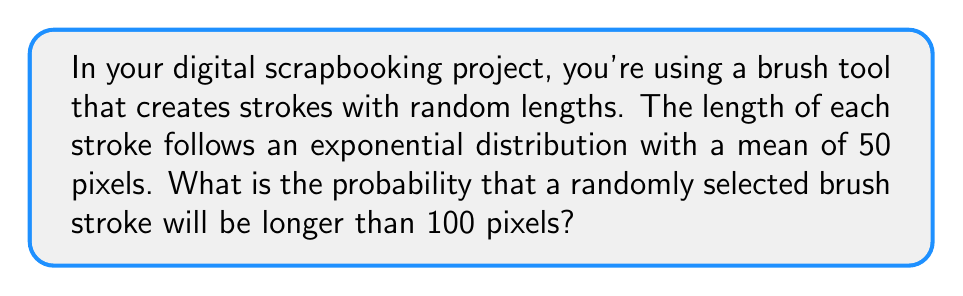Provide a solution to this math problem. Let's approach this step-by-step:

1) The brush stroke lengths follow an exponential distribution with mean $\lambda^{-1} = 50$ pixels.

2) For an exponential distribution, $\lambda = \frac{1}{\text{mean}} = \frac{1}{50}$.

3) We want to find $P(X > 100)$, where $X$ is the length of a brush stroke.

4) For an exponential distribution, the cumulative distribution function (CDF) is:

   $F(x) = 1 - e^{-\lambda x}$ for $x \geq 0$

5) Therefore, $P(X > x) = 1 - F(x) = e^{-\lambda x}$

6) Substituting our values:

   $P(X > 100) = e^{-\frac{1}{50} \cdot 100}$

7) Simplifying:

   $P(X > 100) = e^{-2}$

8) Calculating this value:

   $P(X > 100) \approx 0.1353$

Thus, the probability that a randomly selected brush stroke will be longer than 100 pixels is approximately 0.1353 or about 13.53%.
Answer: $e^{-2} \approx 0.1353$ 